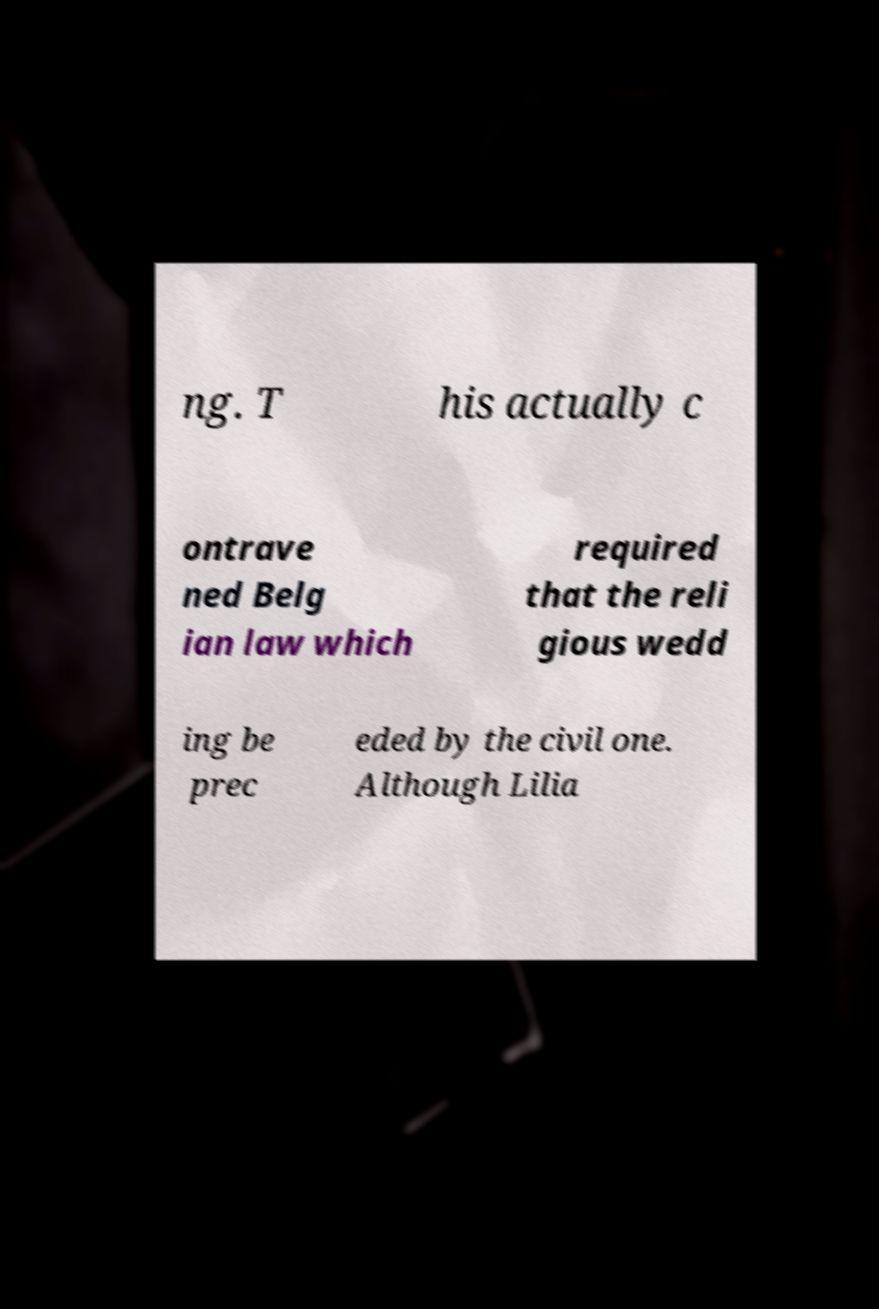Please read and relay the text visible in this image. What does it say? ng. T his actually c ontrave ned Belg ian law which required that the reli gious wedd ing be prec eded by the civil one. Although Lilia 